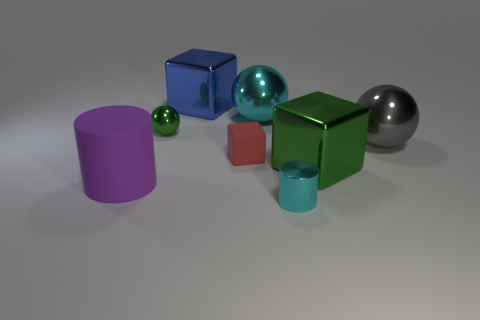What can you infer about the lighting in this image? The lighting in the image appears to be diffused and coming from above, as indicated by the soft shadows directly underneath the objects. The lack of harsh shadows suggests that the light source is neither overly strong nor focused, resembling that of an ambient light commonly used in visualization to simulate a natural and evenly lit environment. 